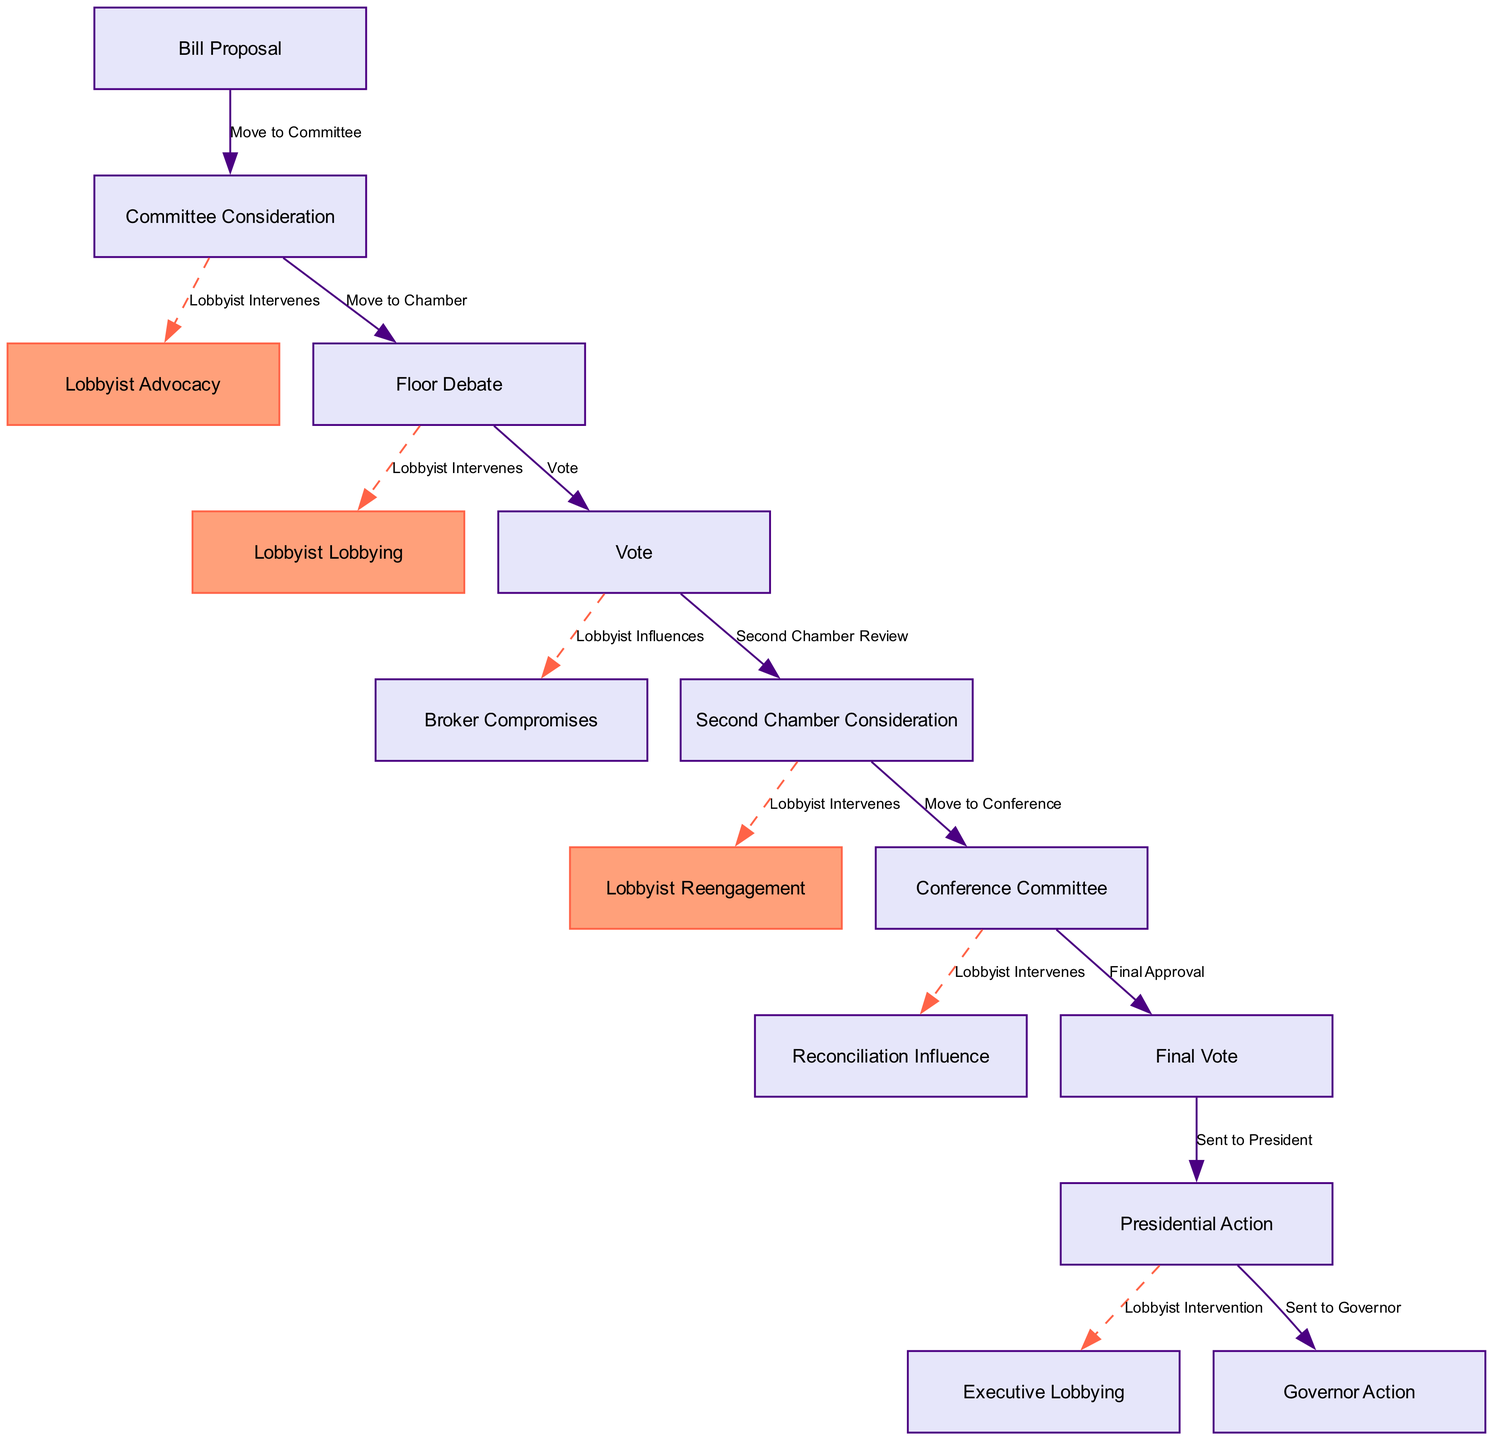What is the first step in the legislative process? The first step is the "Bill Proposal," where a new bill is initiated by a legislator, as shown in the diagram.
Answer: Bill Proposal How many lobbyist intervention points are represented in the diagram? There are six distinct points in the diagram where lobbyist intervention is indicated, specifically noted in the labeled nodes and edges.
Answer: Six Which node signifies the second chamber's review of the bill? The node labeled "Second Chamber Consideration" represents the review, debate, and voting process of the bill in the second chamber.
Answer: Second Chamber Consideration What action follows the "Vote" node in the process? After the "Vote" node, the process leads to the "Second Chamber Consideration," indicating that the bill is reviewed by the second chamber after a vote in the first chamber.
Answer: Second Chamber Consideration Which node represents the stage where the bill is sent to the president? The "Presidential Action" node indicates that the bill has been sent to the President for approval after passing both chambers.
Answer: Presidential Action At which step do lobbyists engage with the executive branch? Lobbyists engage with the executive branch during the "Executive Lobbying" step, where they lobby for the signing or veto of the bill.
Answer: Executive Lobbying How does the "Committee Consideration" relate to lobbyist advocacy? The arrow labeled "Lobbyist Intervenes" indicates that lobbyist advocacy occurs during the "Committee Consideration" stage, showing the connection and influence of lobbyists at this point.
Answer: Lobbyist Intervenes What is required for the bill to proceed from the "Chamber Votes" to the "Second Chamber Review"? A successful vote is required in the "Chamber Votes" step for the bill to move on to the "Second Chamber Review." The vote confirms the bill's passage in the first chamber.
Answer: Vote In which node do lobbyists broker compromises? Lobbyists broker compromises in the "Broker Compromises" node as indicated following the initial chamber's vote in the legislative flow process.
Answer: Broker Compromises 